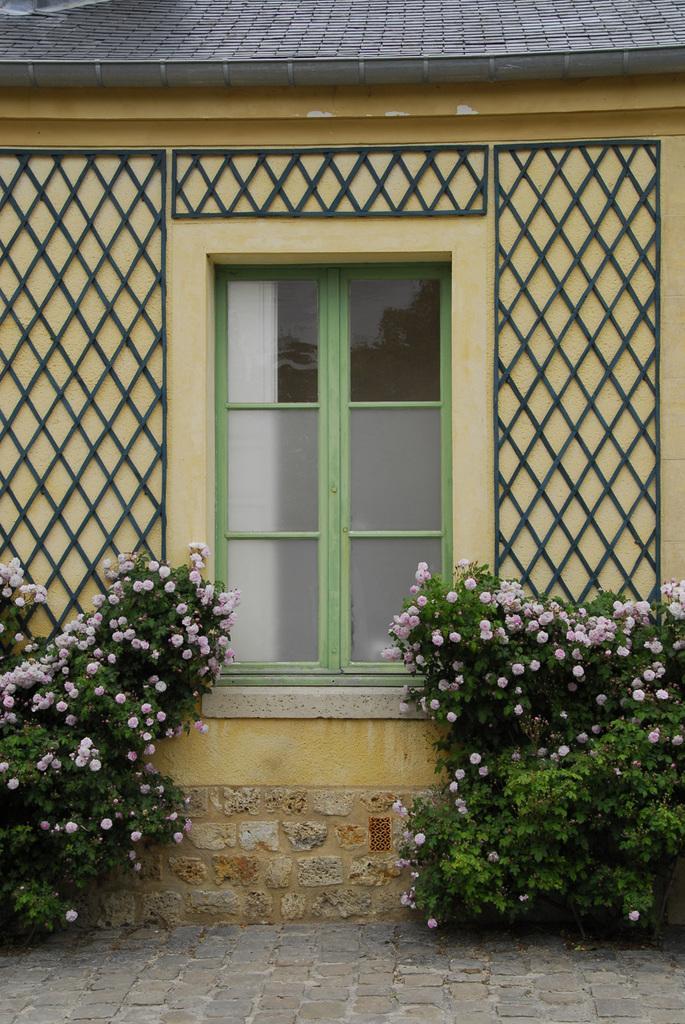Could you give a brief overview of what you see in this image? In this image, we can see the wall with windows and some objects. We can also see some plants with flowers. We can see the ground and some object at the top. 